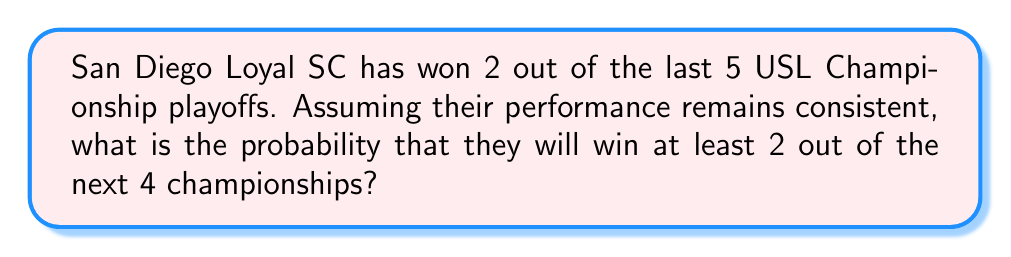Show me your answer to this math problem. Let's approach this step-by-step:

1) First, we need to calculate the probability of San Diego Loyal SC winning a single championship. Based on past performance:

   $P(\text{win}) = \frac{2}{5} = 0.4$

2) Now, we need to find the probability of winning at least 2 out of 4 championships. This can be calculated by finding the probability of winning exactly 2, 3, or 4 championships.

3) We can use the binomial probability formula:

   $P(X = k) = \binom{n}{k} p^k (1-p)^{n-k}$

   Where:
   $n$ = number of trials (4 in this case)
   $k$ = number of successes
   $p$ = probability of success on a single trial (0.4)

4) Calculate the probability for each case:

   For 2 wins: $P(X = 2) = \binom{4}{2} (0.4)^2 (0.6)^2 = 6 \times 0.16 \times 0.36 = 0.3456$

   For 3 wins: $P(X = 3) = \binom{4}{3} (0.4)^3 (0.6)^1 = 4 \times 0.064 \times 0.6 = 0.1536$

   For 4 wins: $P(X = 4) = \binom{4}{4} (0.4)^4 (0.6)^0 = 1 \times 0.0256 \times 1 = 0.0256$

5) Sum these probabilities:

   $P(\text{at least 2 wins}) = 0.3456 + 0.1536 + 0.0256 = 0.5248$
Answer: $0.5248$ or $52.48\%$ 